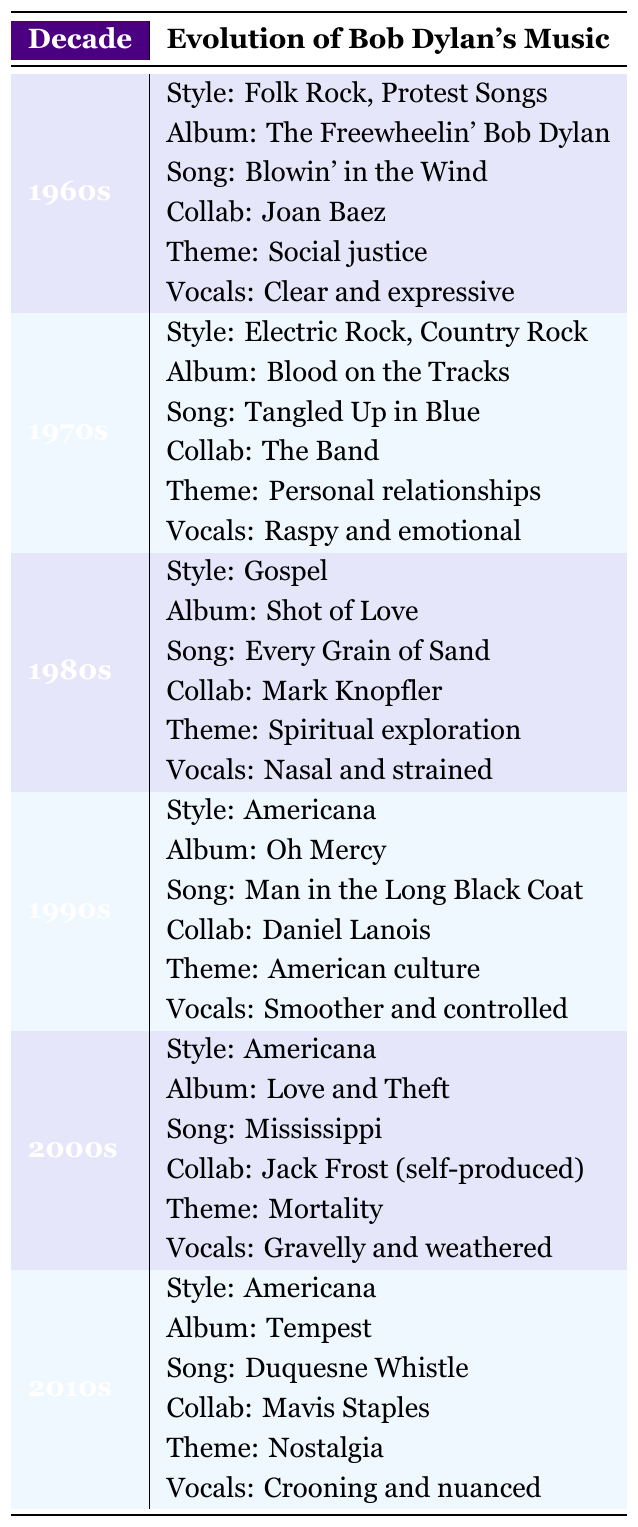What musical style did Bob Dylan primarily embrace in the 1980s? In the 1980s row of the table, it states that the musical style was Gospel.
Answer: Gospel Which album is associated with the 2000s decade? According to the table, the notable album for the 2000s is "Love and Theft."
Answer: Love and Theft Did Bob Dylan collaborate with Mavis Staples in the 2010s? The table shows that Bob Dylan's collaboration in the 2010s was indeed with Mavis Staples.
Answer: Yes What were the primary lyrical themes in the 1970s? Referring to the 1970s section, the primary lyrical theme is Personal relationships.
Answer: Personal relationships Which vocal evolution is noted for the 1990s? The 1990s section specifies that the vocal evolution during this period was smoother and controlled.
Answer: Smoother and controlled How many decades feature Americana as a musical style? Americana is listed as the musical style in three decades: the 1990s, 2000s, and 2010s.
Answer: Three decades What is the iconic song from the 1960s? The iconic song listed for the 1960s is "Blowin' in the Wind."
Answer: Blowin' in the Wind Which collaboration was noted for the 1980s? The table indicates that Bob Dylan collaborated with Mark Knopfler in the 1980s.
Answer: Mark Knopfler In what decade did Bob Dylan's vocal style evolve to become gravelly and weathered? According to the 2000s entry, his vocal style was described as gravelly and weathered during that decade.
Answer: 2000s What change in vocal style is observed from the 1980s to the 1990s? The vocal style changed from nasal and strained in the 1980s to smoother and controlled in the 1990s.
Answer: Nasal to smoother Which lyrical theme remained consistent across the decades mentioned? The theme of social justice appears only in the 1960s, while other themes like Americana appear in later decades, indicating there isn't a consistent theme across all decades.
Answer: No consistent theme 